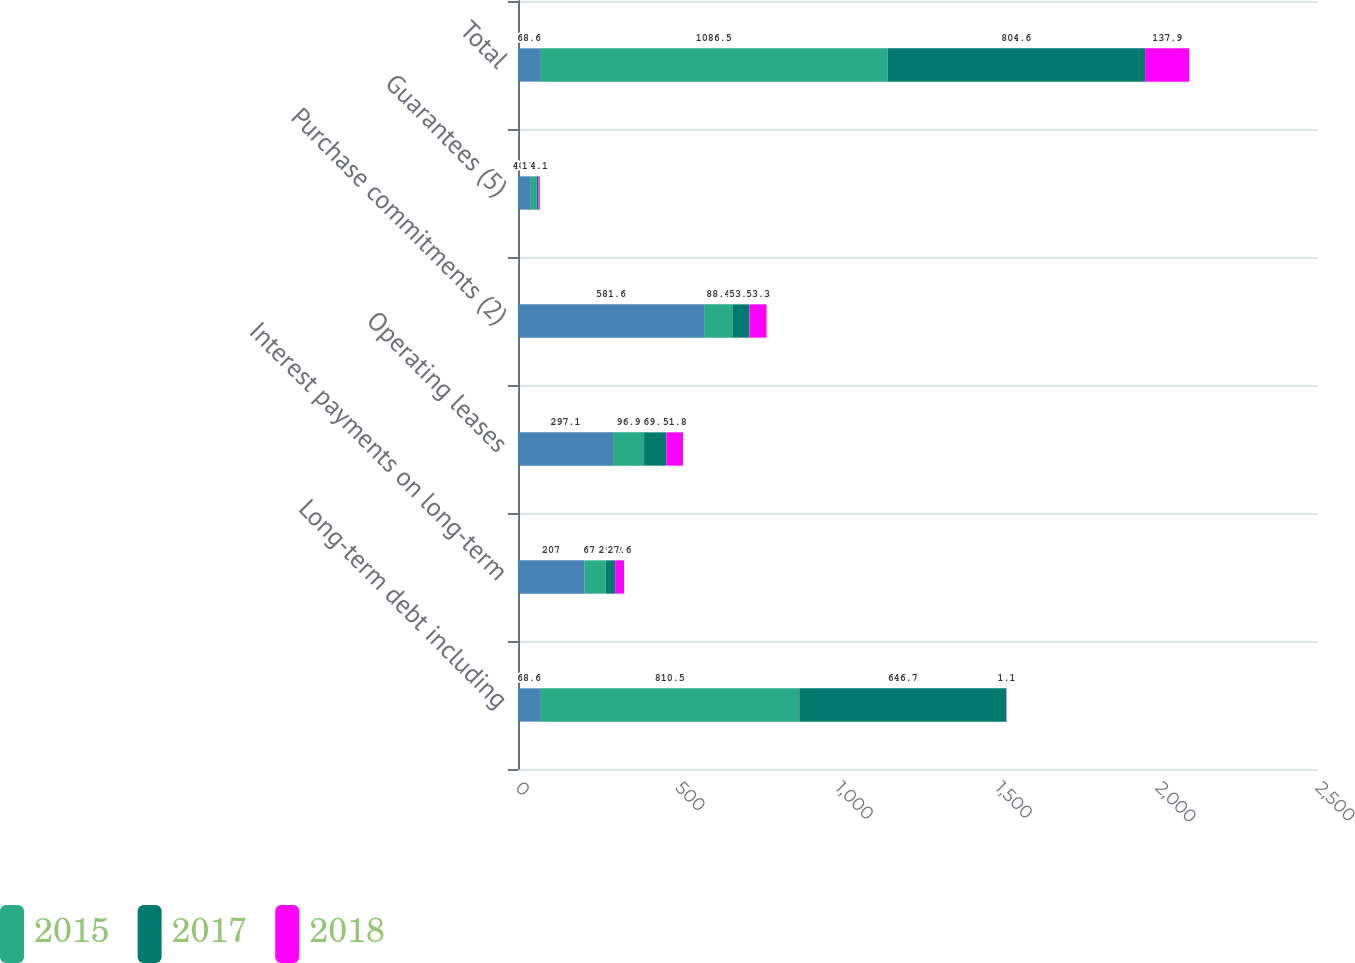Convert chart to OTSL. <chart><loc_0><loc_0><loc_500><loc_500><stacked_bar_chart><ecel><fcel>Long-term debt including<fcel>Interest payments on long-term<fcel>Operating leases<fcel>Purchase commitments (2)<fcel>Guarantees (5)<fcel>Total<nl><fcel>nan<fcel>68.6<fcel>207<fcel>297.1<fcel>581.6<fcel>40.1<fcel>68.6<nl><fcel>2015<fcel>810.5<fcel>67.3<fcel>96.9<fcel>88.4<fcel>18.5<fcel>1086.5<nl><fcel>2017<fcel>646.7<fcel>29.3<fcel>69.9<fcel>53.4<fcel>5.3<fcel>804.6<nl><fcel>2018<fcel>1.1<fcel>27.6<fcel>51.8<fcel>53.3<fcel>4.1<fcel>137.9<nl></chart> 